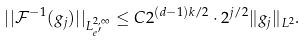Convert formula to latex. <formula><loc_0><loc_0><loc_500><loc_500>| | \mathcal { F } ^ { - 1 } ( g _ { j } ) | | _ { L ^ { 2 , \infty } _ { e ^ { \prime } } } \leq C 2 ^ { ( d - 1 ) k / 2 } \cdot 2 ^ { j / 2 } \| g _ { j } \| _ { L ^ { 2 } } .</formula> 